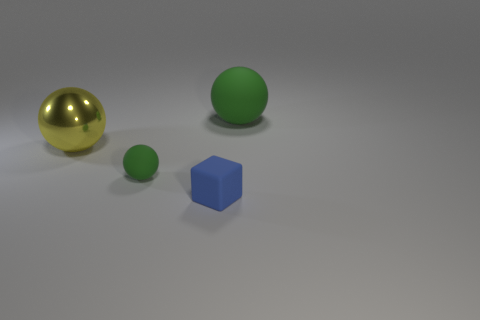Is there a small green thing?
Make the answer very short. Yes. Are there an equal number of green matte balls in front of the large green matte sphere and tiny green rubber spheres?
Your answer should be compact. Yes. What number of other things are the same shape as the blue matte object?
Your answer should be very brief. 0. The yellow thing is what shape?
Make the answer very short. Sphere. Is the material of the tiny blue cube the same as the large green sphere?
Your response must be concise. Yes. Are there an equal number of yellow spheres that are in front of the small green rubber sphere and rubber things that are to the left of the large rubber thing?
Keep it short and to the point. No. Are there any blue matte cubes that are in front of the small matte object that is to the right of the rubber ball in front of the yellow thing?
Provide a succinct answer. No. Does the blue matte cube have the same size as the yellow object?
Offer a very short reply. No. There is a small cube that is in front of the large ball left of the green sphere that is behind the yellow metal thing; what color is it?
Offer a very short reply. Blue. How many small rubber objects have the same color as the big metal sphere?
Offer a terse response. 0. 